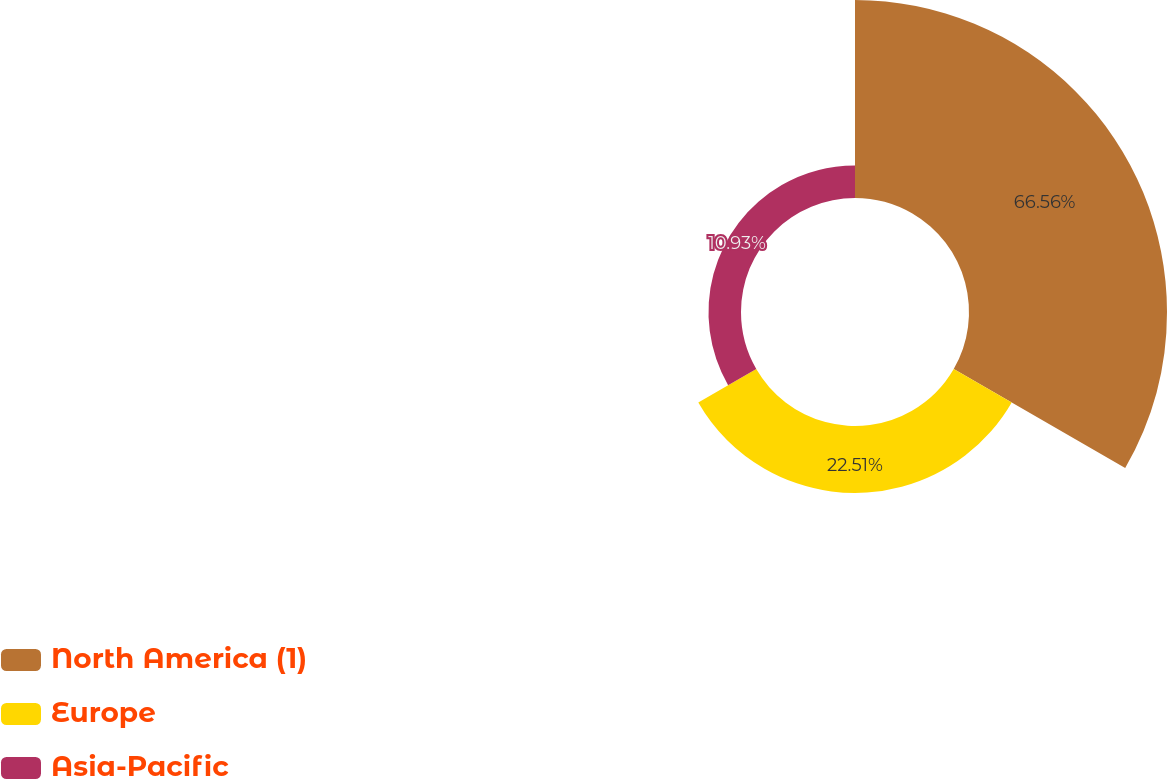Convert chart to OTSL. <chart><loc_0><loc_0><loc_500><loc_500><pie_chart><fcel>North America (1)<fcel>Europe<fcel>Asia-Pacific<nl><fcel>66.57%<fcel>22.51%<fcel>10.93%<nl></chart> 